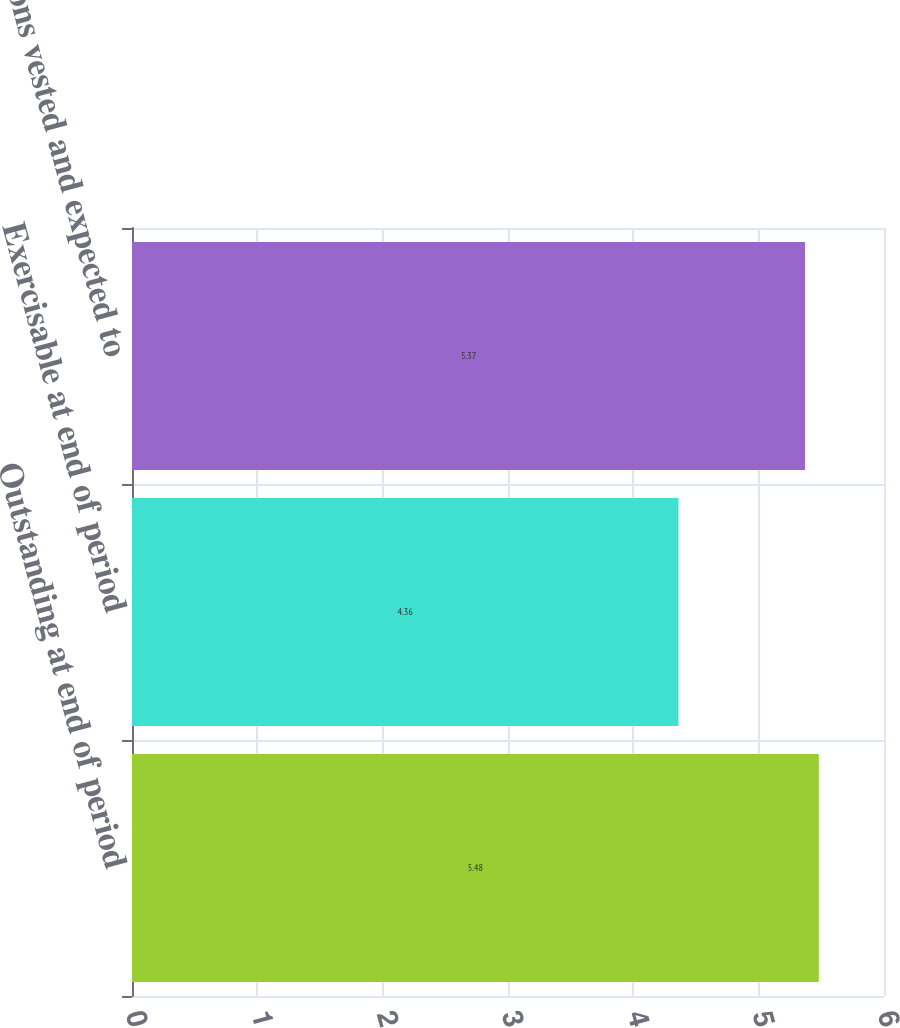Convert chart. <chart><loc_0><loc_0><loc_500><loc_500><bar_chart><fcel>Outstanding at end of period<fcel>Exercisable at end of period<fcel>Options vested and expected to<nl><fcel>5.48<fcel>4.36<fcel>5.37<nl></chart> 